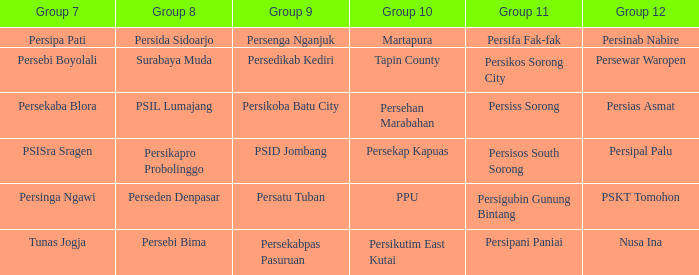When persikos sorong city competed in group 11, who took part in group 7? Persebi Boyolali. 